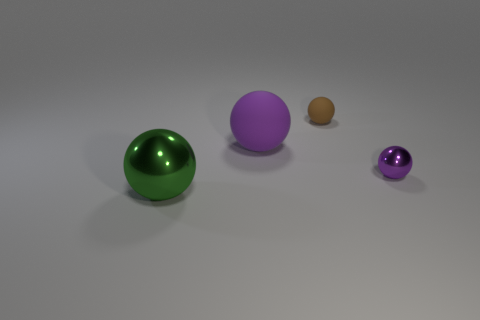Subtract 1 balls. How many balls are left? 3 Add 2 small brown spheres. How many objects exist? 6 Add 1 small balls. How many small balls exist? 3 Subtract 0 purple blocks. How many objects are left? 4 Subtract all large purple rubber things. Subtract all tiny rubber spheres. How many objects are left? 2 Add 4 shiny objects. How many shiny objects are left? 6 